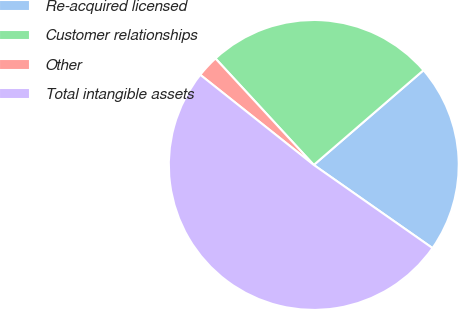Convert chart to OTSL. <chart><loc_0><loc_0><loc_500><loc_500><pie_chart><fcel>Re-acquired licensed<fcel>Customer relationships<fcel>Other<fcel>Total intangible assets<nl><fcel>21.06%<fcel>25.53%<fcel>2.45%<fcel>50.96%<nl></chart> 